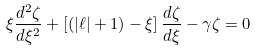Convert formula to latex. <formula><loc_0><loc_0><loc_500><loc_500>\xi \frac { d ^ { 2 } \zeta } { d \xi ^ { 2 } } + \left [ ( | \ell | + 1 ) - \xi \right ] \frac { d \zeta } { d \xi } - \gamma \zeta = 0</formula> 